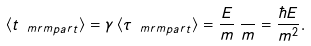<formula> <loc_0><loc_0><loc_500><loc_500>\langle t _ { \ m r m { p a r t } } \rangle = \gamma \, \langle \tau _ { \ m r m { p a r t } } \rangle = \frac { E } { m } \, \frac { } { m } = \frac { \hbar { E } } { m ^ { 2 } } .</formula> 